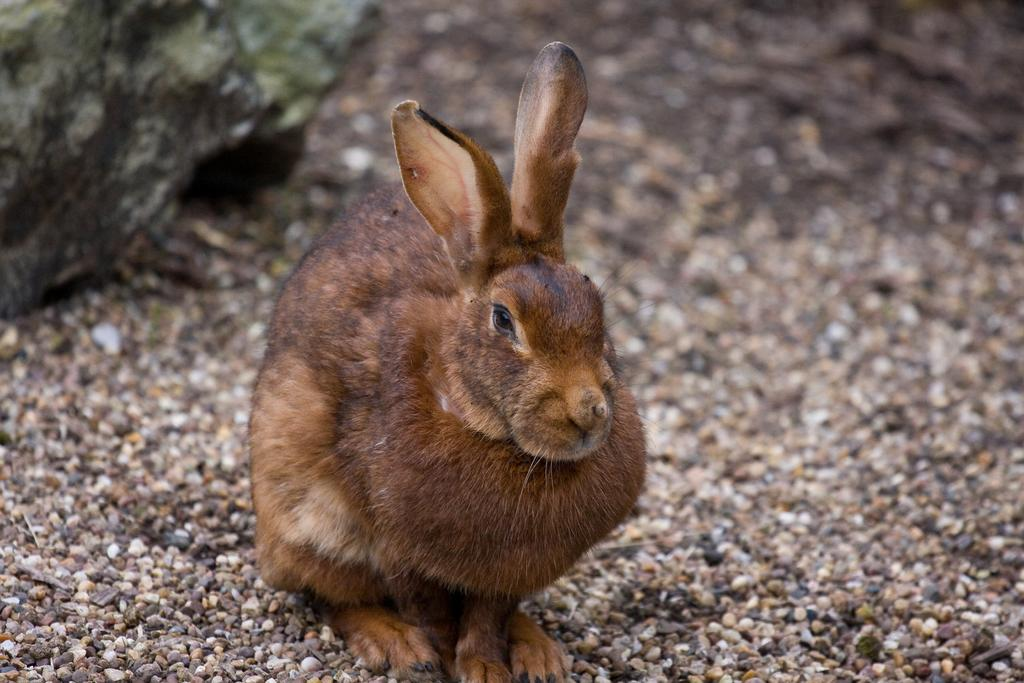What animal is present in the image? There is a rabbit in the image. What colors can be seen on the rabbit? The rabbit is black and brown in color. What geological feature is visible in the image? There is a rock on the side in the image. What type of ground surface is depicted in the image? There are small stones on the ground in the image. What type of poison is the rabbit using to protect itself in the image? There is no poison present in the image, nor is the rabbit using any to protect itself. 